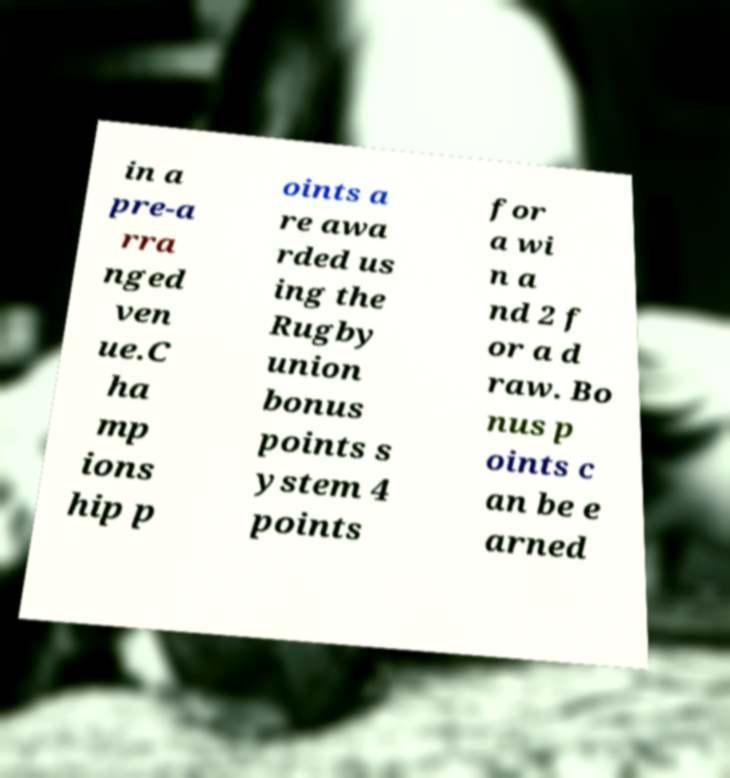Please read and relay the text visible in this image. What does it say? in a pre-a rra nged ven ue.C ha mp ions hip p oints a re awa rded us ing the Rugby union bonus points s ystem 4 points for a wi n a nd 2 f or a d raw. Bo nus p oints c an be e arned 